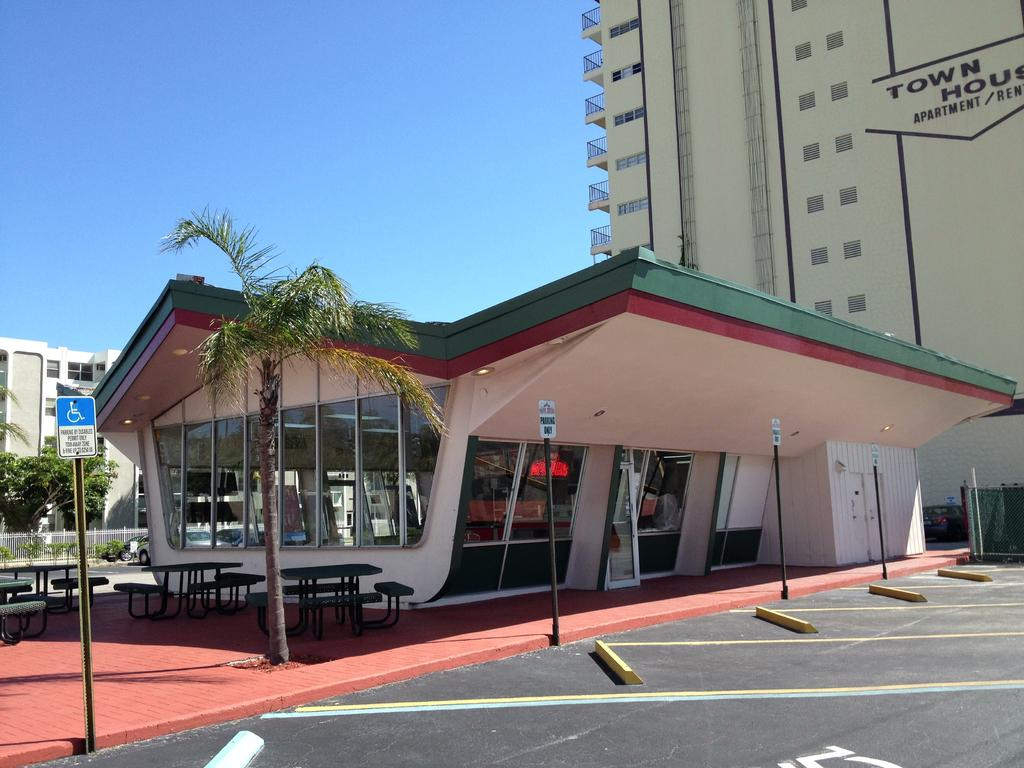What type of structures can be seen in the image? There are buildings in the image. Can you describe any text or signage on the buildings? Yes, there is text on at least one building. What type of seating is available in the image? There are benches in the image. What are the poles with boards used for in the image? The poles with boards might be used for signage or advertisements. What type of vegetation is present in the image? There are trees in the image. What type of barrier is present in the image? There is a fence in the image. What type of transportation is visible on the road in the image? There are vehicles on the road in the image. What part of the natural environment is visible in the background of the image? The sky is visible in the background of the image. Can you describe the smoke coming from the carpenter's workshop in the image? There is no carpenter's workshop or smoke present in the image. What type of conversation is happening between the trees in the image? There is no conversation happening between the trees in the image, as trees do not have the ability to talk. 